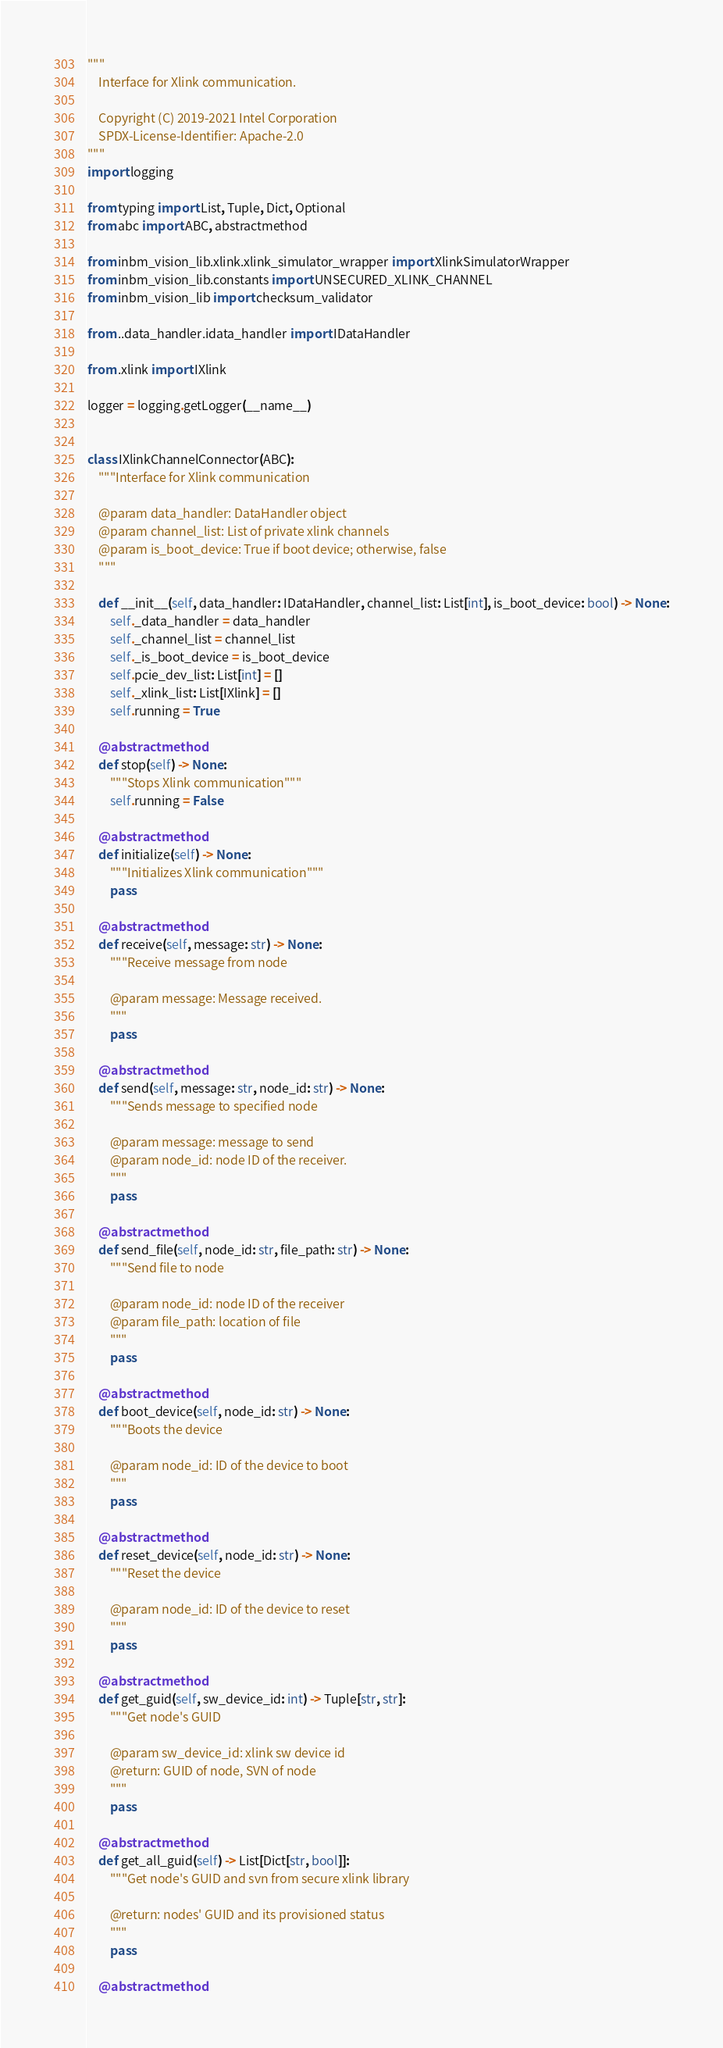Convert code to text. <code><loc_0><loc_0><loc_500><loc_500><_Python_>"""
    Interface for Xlink communication.

    Copyright (C) 2019-2021 Intel Corporation
    SPDX-License-Identifier: Apache-2.0
"""
import logging

from typing import List, Tuple, Dict, Optional
from abc import ABC, abstractmethod

from inbm_vision_lib.xlink.xlink_simulator_wrapper import XlinkSimulatorWrapper
from inbm_vision_lib.constants import UNSECURED_XLINK_CHANNEL
from inbm_vision_lib import checksum_validator

from ..data_handler.idata_handler import IDataHandler

from .xlink import IXlink

logger = logging.getLogger(__name__)


class IXlinkChannelConnector(ABC):
    """Interface for Xlink communication

    @param data_handler: DataHandler object
    @param channel_list: List of private xlink channels
    @param is_boot_device: True if boot device; otherwise, false
    """

    def __init__(self, data_handler: IDataHandler, channel_list: List[int], is_boot_device: bool) -> None:
        self._data_handler = data_handler
        self._channel_list = channel_list
        self._is_boot_device = is_boot_device
        self.pcie_dev_list: List[int] = []
        self._xlink_list: List[IXlink] = []
        self.running = True

    @abstractmethod
    def stop(self) -> None:
        """Stops Xlink communication"""
        self.running = False

    @abstractmethod
    def initialize(self) -> None:
        """Initializes Xlink communication"""
        pass

    @abstractmethod
    def receive(self, message: str) -> None:
        """Receive message from node

        @param message: Message received.
        """
        pass

    @abstractmethod
    def send(self, message: str, node_id: str) -> None:
        """Sends message to specified node

        @param message: message to send
        @param node_id: node ID of the receiver.
        """
        pass

    @abstractmethod
    def send_file(self, node_id: str, file_path: str) -> None:
        """Send file to node

        @param node_id: node ID of the receiver
        @param file_path: location of file
        """
        pass

    @abstractmethod
    def boot_device(self, node_id: str) -> None:
        """Boots the device

        @param node_id: ID of the device to boot
        """
        pass

    @abstractmethod
    def reset_device(self, node_id: str) -> None:
        """Reset the device

        @param node_id: ID of the device to reset
        """
        pass

    @abstractmethod
    def get_guid(self, sw_device_id: int) -> Tuple[str, str]:
        """Get node's GUID 

        @param sw_device_id: xlink sw device id
        @return: GUID of node, SVN of node
        """
        pass

    @abstractmethod
    def get_all_guid(self) -> List[Dict[str, bool]]:
        """Get node's GUID and svn from secure xlink library

        @return: nodes' GUID and its provisioned status
        """
        pass

    @abstractmethod</code> 